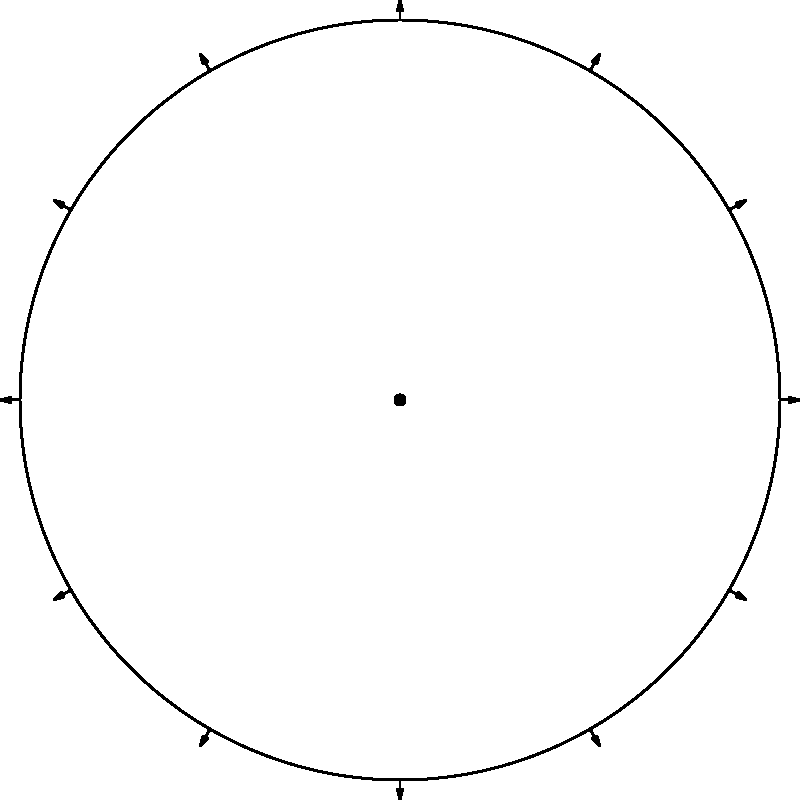In a circular coffee plantation, a disease outbreak has been detected at three locations: $(4, 120^\circ)$, $(4, 210^\circ)$, and $(4, 330^\circ)$ using polar coordinates $(r, \theta)$. If the disease spreads uniformly in all directions at a rate of 0.5 units per week, after how many weeks will the entire plantation be affected? (Assume the plantation has a radius of 4 units and the disease spreads continue until they meet.) Let's approach this step-by-step:

1) First, we need to understand that the disease will spread in circular patterns from each point of origin.

2) The question is essentially asking when these circular spreads will cover the entire plantation.

3) The farthest point from any disease origin will be the point exactly between two origins, on the edge of the plantation.

4) To find this point, we need to calculate the angle between any two adjacent disease origins:
   $330^\circ - 210^\circ = 120^\circ$
   $120^\circ - 330^\circ = 150^\circ$ (or $-210^\circ$, which is equivalent)
   $210^\circ - 120^\circ = 90^\circ$

   The smallest angle is $90^\circ$.

5) The farthest point will be $45^\circ$ (half of $90^\circ$) from two adjacent disease origins.

6) We can calculate the distance this point is from a disease origin using the law of cosines:
   $d^2 = 4^2 + 4^2 - 2(4)(4)\cos(45^\circ)$
   $d^2 = 32 - 32\cos(45^\circ) \approx 9.3726$
   $d \approx 3.0615$ units

7) The disease needs to spread 3.0615 units to reach this farthest point.

8) At a rate of 0.5 units per week, this will take:
   $3.0615 / 0.5 = 6.123$ weeks

9) Rounding up to ensure complete coverage, it will take 7 weeks.
Answer: 7 weeks 